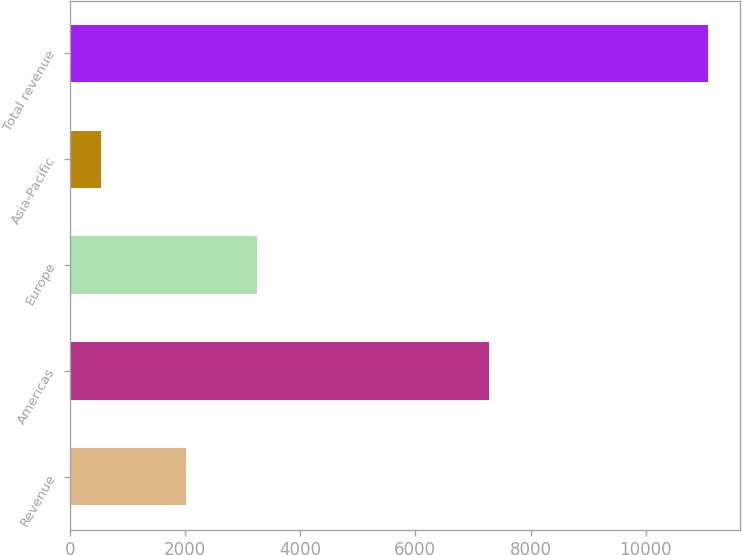<chart> <loc_0><loc_0><loc_500><loc_500><bar_chart><fcel>Revenue<fcel>Americas<fcel>Europe<fcel>Asia-Pacific<fcel>Total revenue<nl><fcel>2014<fcel>7286<fcel>3246<fcel>549<fcel>11081<nl></chart> 